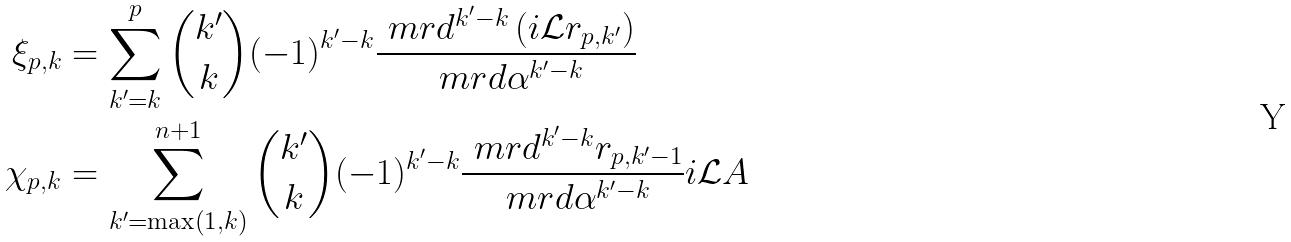Convert formula to latex. <formula><loc_0><loc_0><loc_500><loc_500>\xi _ { p , k } & = \sum _ { k ^ { \prime } = k } ^ { p } { { k ^ { \prime } } \choose { k } } ( - 1 ) ^ { k ^ { \prime } - k } \frac { \ m r d ^ { k ^ { \prime } - k } \left ( i \mathcal { L } r _ { p , k ^ { \prime } } \right ) } { \ m r d \alpha ^ { k ^ { \prime } - k } } \\ \chi _ { p , k } & = \sum _ { k ^ { \prime } = \max \left ( 1 , k \right ) } ^ { n + 1 } { { k ^ { \prime } } \choose { k } } ( - 1 ) ^ { k ^ { \prime } - k } \frac { \ m r d ^ { k ^ { \prime } - k } r _ { p , k ^ { \prime } - 1 } } { \ m r d \alpha ^ { k ^ { \prime } - k } } i \mathcal { L } A</formula> 